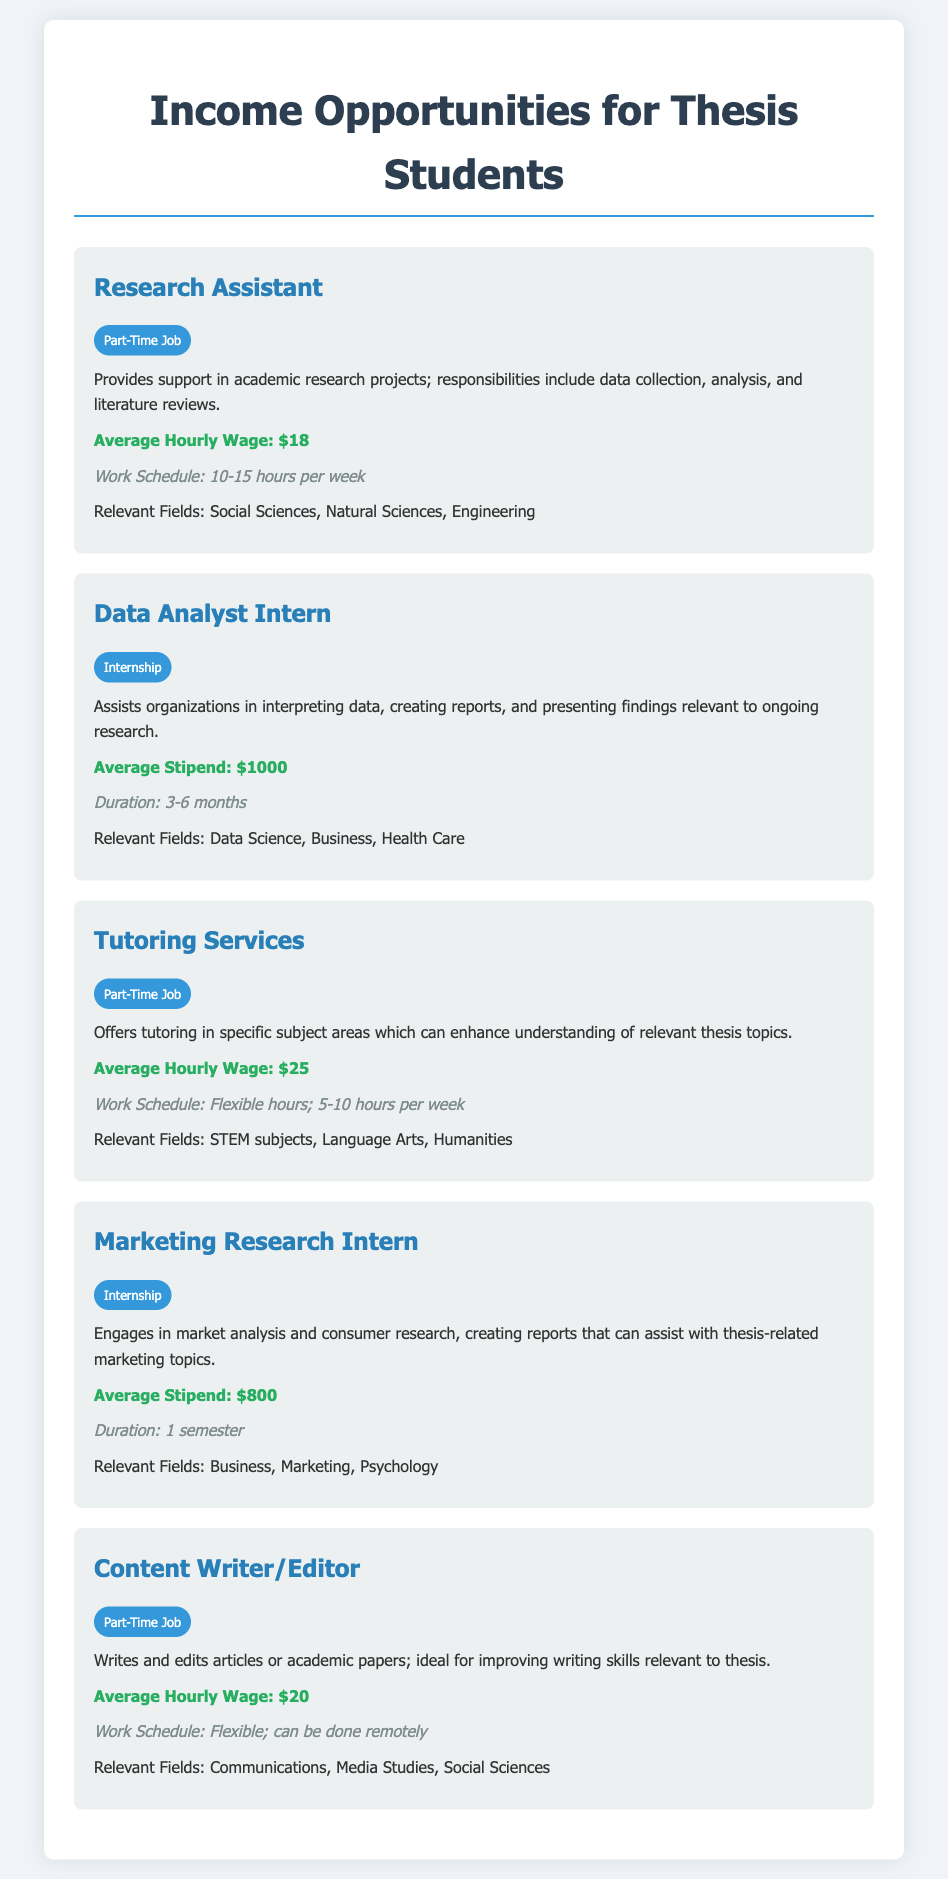What is the average hourly wage for a Research Assistant? The average hourly wage for a Research Assistant is provided in the document under the relevant section.
Answer: $18 What is the average stipend for a Data Analyst Intern? The document includes details about the average stipend for a Data Analyst Intern as part of its income opportunities.
Answer: $1000 How many hours per week is a Tutoring Services job expected to require? The expected work schedule of the Tutoring Services position is detailed in the document.
Answer: 5-10 hours What is the duration of the Marketing Research Internship? The document specifies the duration for the Marketing Research Internship within the relevant section.
Answer: 1 semester Which job offers the highest average hourly wage? The document lists multiple job opportunities along with their average wages, allowing us to identify the one with the highest amount.
Answer: Tutoring Services What relevant fields are associated with the Content Writer/Editor position? The document outlines the relevant fields for each opportunity, allowing for a straightforward retrieval of this information.
Answer: Communications, Media Studies, Social Sciences What type of job is the Data Analyst position categorized as? The document classifies each opportunity clearly, making it easy to identify the category for the Data Analyst position.
Answer: Internship Which opportunity involves flexible hours? The document describes the working conditions, allowing us to determine which option includes flexible hours.
Answer: Tutoring Services, Content Writer/Editor 